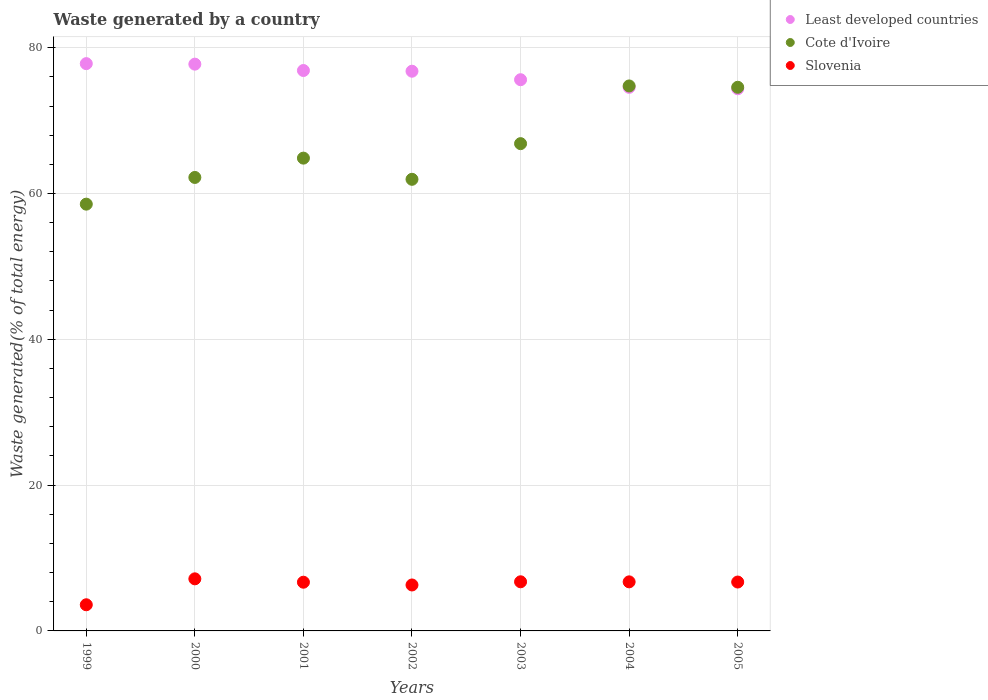How many different coloured dotlines are there?
Offer a terse response. 3. What is the total waste generated in Cote d'Ivoire in 1999?
Keep it short and to the point. 58.54. Across all years, what is the maximum total waste generated in Cote d'Ivoire?
Offer a terse response. 74.76. Across all years, what is the minimum total waste generated in Slovenia?
Provide a short and direct response. 3.59. In which year was the total waste generated in Slovenia minimum?
Your response must be concise. 1999. What is the total total waste generated in Slovenia in the graph?
Ensure brevity in your answer.  43.89. What is the difference between the total waste generated in Least developed countries in 2002 and that in 2004?
Give a very brief answer. 2.21. What is the difference between the total waste generated in Slovenia in 2000 and the total waste generated in Least developed countries in 2005?
Offer a terse response. -67.23. What is the average total waste generated in Cote d'Ivoire per year?
Make the answer very short. 66.25. In the year 2001, what is the difference between the total waste generated in Cote d'Ivoire and total waste generated in Slovenia?
Your response must be concise. 58.17. What is the ratio of the total waste generated in Slovenia in 2001 to that in 2002?
Your response must be concise. 1.06. What is the difference between the highest and the second highest total waste generated in Least developed countries?
Offer a terse response. 0.07. What is the difference between the highest and the lowest total waste generated in Slovenia?
Give a very brief answer. 3.56. Is the total waste generated in Least developed countries strictly greater than the total waste generated in Slovenia over the years?
Provide a short and direct response. Yes. How many years are there in the graph?
Your answer should be very brief. 7. What is the difference between two consecutive major ticks on the Y-axis?
Provide a succinct answer. 20. Are the values on the major ticks of Y-axis written in scientific E-notation?
Ensure brevity in your answer.  No. How many legend labels are there?
Ensure brevity in your answer.  3. What is the title of the graph?
Keep it short and to the point. Waste generated by a country. Does "Sierra Leone" appear as one of the legend labels in the graph?
Your answer should be very brief. No. What is the label or title of the X-axis?
Offer a terse response. Years. What is the label or title of the Y-axis?
Offer a very short reply. Waste generated(% of total energy). What is the Waste generated(% of total energy) in Least developed countries in 1999?
Offer a very short reply. 77.82. What is the Waste generated(% of total energy) in Cote d'Ivoire in 1999?
Provide a succinct answer. 58.54. What is the Waste generated(% of total energy) of Slovenia in 1999?
Ensure brevity in your answer.  3.59. What is the Waste generated(% of total energy) in Least developed countries in 2000?
Give a very brief answer. 77.75. What is the Waste generated(% of total energy) of Cote d'Ivoire in 2000?
Your response must be concise. 62.2. What is the Waste generated(% of total energy) in Slovenia in 2000?
Make the answer very short. 7.14. What is the Waste generated(% of total energy) of Least developed countries in 2001?
Your answer should be compact. 76.87. What is the Waste generated(% of total energy) in Cote d'Ivoire in 2001?
Your answer should be very brief. 64.85. What is the Waste generated(% of total energy) in Slovenia in 2001?
Offer a terse response. 6.68. What is the Waste generated(% of total energy) in Least developed countries in 2002?
Give a very brief answer. 76.78. What is the Waste generated(% of total energy) in Cote d'Ivoire in 2002?
Offer a very short reply. 61.95. What is the Waste generated(% of total energy) in Slovenia in 2002?
Make the answer very short. 6.3. What is the Waste generated(% of total energy) of Least developed countries in 2003?
Provide a succinct answer. 75.61. What is the Waste generated(% of total energy) of Cote d'Ivoire in 2003?
Give a very brief answer. 66.84. What is the Waste generated(% of total energy) of Slovenia in 2003?
Your answer should be compact. 6.74. What is the Waste generated(% of total energy) of Least developed countries in 2004?
Give a very brief answer. 74.56. What is the Waste generated(% of total energy) of Cote d'Ivoire in 2004?
Keep it short and to the point. 74.76. What is the Waste generated(% of total energy) in Slovenia in 2004?
Give a very brief answer. 6.73. What is the Waste generated(% of total energy) in Least developed countries in 2005?
Provide a short and direct response. 74.37. What is the Waste generated(% of total energy) in Cote d'Ivoire in 2005?
Your answer should be very brief. 74.57. What is the Waste generated(% of total energy) of Slovenia in 2005?
Offer a terse response. 6.71. Across all years, what is the maximum Waste generated(% of total energy) in Least developed countries?
Your answer should be compact. 77.82. Across all years, what is the maximum Waste generated(% of total energy) of Cote d'Ivoire?
Ensure brevity in your answer.  74.76. Across all years, what is the maximum Waste generated(% of total energy) in Slovenia?
Ensure brevity in your answer.  7.14. Across all years, what is the minimum Waste generated(% of total energy) of Least developed countries?
Offer a very short reply. 74.37. Across all years, what is the minimum Waste generated(% of total energy) of Cote d'Ivoire?
Offer a terse response. 58.54. Across all years, what is the minimum Waste generated(% of total energy) of Slovenia?
Your response must be concise. 3.59. What is the total Waste generated(% of total energy) in Least developed countries in the graph?
Make the answer very short. 533.76. What is the total Waste generated(% of total energy) in Cote d'Ivoire in the graph?
Make the answer very short. 463.72. What is the total Waste generated(% of total energy) in Slovenia in the graph?
Keep it short and to the point. 43.89. What is the difference between the Waste generated(% of total energy) in Least developed countries in 1999 and that in 2000?
Ensure brevity in your answer.  0.07. What is the difference between the Waste generated(% of total energy) in Cote d'Ivoire in 1999 and that in 2000?
Make the answer very short. -3.66. What is the difference between the Waste generated(% of total energy) in Slovenia in 1999 and that in 2000?
Keep it short and to the point. -3.56. What is the difference between the Waste generated(% of total energy) of Least developed countries in 1999 and that in 2001?
Ensure brevity in your answer.  0.94. What is the difference between the Waste generated(% of total energy) in Cote d'Ivoire in 1999 and that in 2001?
Give a very brief answer. -6.31. What is the difference between the Waste generated(% of total energy) of Slovenia in 1999 and that in 2001?
Ensure brevity in your answer.  -3.09. What is the difference between the Waste generated(% of total energy) of Least developed countries in 1999 and that in 2002?
Offer a terse response. 1.04. What is the difference between the Waste generated(% of total energy) in Cote d'Ivoire in 1999 and that in 2002?
Give a very brief answer. -3.41. What is the difference between the Waste generated(% of total energy) of Slovenia in 1999 and that in 2002?
Ensure brevity in your answer.  -2.72. What is the difference between the Waste generated(% of total energy) of Least developed countries in 1999 and that in 2003?
Provide a short and direct response. 2.21. What is the difference between the Waste generated(% of total energy) of Cote d'Ivoire in 1999 and that in 2003?
Ensure brevity in your answer.  -8.3. What is the difference between the Waste generated(% of total energy) of Slovenia in 1999 and that in 2003?
Your response must be concise. -3.15. What is the difference between the Waste generated(% of total energy) in Least developed countries in 1999 and that in 2004?
Your answer should be compact. 3.25. What is the difference between the Waste generated(% of total energy) in Cote d'Ivoire in 1999 and that in 2004?
Your answer should be very brief. -16.21. What is the difference between the Waste generated(% of total energy) in Slovenia in 1999 and that in 2004?
Give a very brief answer. -3.14. What is the difference between the Waste generated(% of total energy) in Least developed countries in 1999 and that in 2005?
Offer a very short reply. 3.45. What is the difference between the Waste generated(% of total energy) in Cote d'Ivoire in 1999 and that in 2005?
Your answer should be very brief. -16.03. What is the difference between the Waste generated(% of total energy) in Slovenia in 1999 and that in 2005?
Make the answer very short. -3.12. What is the difference between the Waste generated(% of total energy) in Least developed countries in 2000 and that in 2001?
Provide a succinct answer. 0.87. What is the difference between the Waste generated(% of total energy) in Cote d'Ivoire in 2000 and that in 2001?
Offer a terse response. -2.65. What is the difference between the Waste generated(% of total energy) of Slovenia in 2000 and that in 2001?
Your answer should be compact. 0.46. What is the difference between the Waste generated(% of total energy) in Least developed countries in 2000 and that in 2002?
Your response must be concise. 0.97. What is the difference between the Waste generated(% of total energy) of Cote d'Ivoire in 2000 and that in 2002?
Your answer should be very brief. 0.25. What is the difference between the Waste generated(% of total energy) in Slovenia in 2000 and that in 2002?
Offer a very short reply. 0.84. What is the difference between the Waste generated(% of total energy) of Least developed countries in 2000 and that in 2003?
Your response must be concise. 2.13. What is the difference between the Waste generated(% of total energy) in Cote d'Ivoire in 2000 and that in 2003?
Your response must be concise. -4.64. What is the difference between the Waste generated(% of total energy) of Slovenia in 2000 and that in 2003?
Ensure brevity in your answer.  0.41. What is the difference between the Waste generated(% of total energy) in Least developed countries in 2000 and that in 2004?
Keep it short and to the point. 3.18. What is the difference between the Waste generated(% of total energy) in Cote d'Ivoire in 2000 and that in 2004?
Ensure brevity in your answer.  -12.55. What is the difference between the Waste generated(% of total energy) of Slovenia in 2000 and that in 2004?
Keep it short and to the point. 0.41. What is the difference between the Waste generated(% of total energy) of Least developed countries in 2000 and that in 2005?
Ensure brevity in your answer.  3.37. What is the difference between the Waste generated(% of total energy) of Cote d'Ivoire in 2000 and that in 2005?
Ensure brevity in your answer.  -12.37. What is the difference between the Waste generated(% of total energy) in Slovenia in 2000 and that in 2005?
Offer a terse response. 0.44. What is the difference between the Waste generated(% of total energy) of Least developed countries in 2001 and that in 2002?
Provide a succinct answer. 0.1. What is the difference between the Waste generated(% of total energy) of Cote d'Ivoire in 2001 and that in 2002?
Offer a terse response. 2.9. What is the difference between the Waste generated(% of total energy) in Slovenia in 2001 and that in 2002?
Your answer should be compact. 0.38. What is the difference between the Waste generated(% of total energy) in Least developed countries in 2001 and that in 2003?
Your answer should be compact. 1.26. What is the difference between the Waste generated(% of total energy) of Cote d'Ivoire in 2001 and that in 2003?
Make the answer very short. -1.99. What is the difference between the Waste generated(% of total energy) in Slovenia in 2001 and that in 2003?
Provide a short and direct response. -0.06. What is the difference between the Waste generated(% of total energy) of Least developed countries in 2001 and that in 2004?
Offer a very short reply. 2.31. What is the difference between the Waste generated(% of total energy) in Cote d'Ivoire in 2001 and that in 2004?
Make the answer very short. -9.9. What is the difference between the Waste generated(% of total energy) of Slovenia in 2001 and that in 2004?
Provide a succinct answer. -0.05. What is the difference between the Waste generated(% of total energy) of Least developed countries in 2001 and that in 2005?
Your answer should be compact. 2.5. What is the difference between the Waste generated(% of total energy) in Cote d'Ivoire in 2001 and that in 2005?
Keep it short and to the point. -9.72. What is the difference between the Waste generated(% of total energy) in Slovenia in 2001 and that in 2005?
Offer a very short reply. -0.02. What is the difference between the Waste generated(% of total energy) in Least developed countries in 2002 and that in 2003?
Your response must be concise. 1.17. What is the difference between the Waste generated(% of total energy) of Cote d'Ivoire in 2002 and that in 2003?
Provide a succinct answer. -4.89. What is the difference between the Waste generated(% of total energy) of Slovenia in 2002 and that in 2003?
Offer a terse response. -0.44. What is the difference between the Waste generated(% of total energy) in Least developed countries in 2002 and that in 2004?
Your answer should be compact. 2.21. What is the difference between the Waste generated(% of total energy) in Cote d'Ivoire in 2002 and that in 2004?
Make the answer very short. -12.81. What is the difference between the Waste generated(% of total energy) in Slovenia in 2002 and that in 2004?
Offer a very short reply. -0.43. What is the difference between the Waste generated(% of total energy) in Least developed countries in 2002 and that in 2005?
Your answer should be compact. 2.41. What is the difference between the Waste generated(% of total energy) of Cote d'Ivoire in 2002 and that in 2005?
Keep it short and to the point. -12.62. What is the difference between the Waste generated(% of total energy) of Slovenia in 2002 and that in 2005?
Provide a succinct answer. -0.4. What is the difference between the Waste generated(% of total energy) of Least developed countries in 2003 and that in 2004?
Your response must be concise. 1.05. What is the difference between the Waste generated(% of total energy) of Cote d'Ivoire in 2003 and that in 2004?
Offer a very short reply. -7.92. What is the difference between the Waste generated(% of total energy) in Slovenia in 2003 and that in 2004?
Provide a succinct answer. 0.01. What is the difference between the Waste generated(% of total energy) in Least developed countries in 2003 and that in 2005?
Provide a succinct answer. 1.24. What is the difference between the Waste generated(% of total energy) of Cote d'Ivoire in 2003 and that in 2005?
Keep it short and to the point. -7.73. What is the difference between the Waste generated(% of total energy) of Slovenia in 2003 and that in 2005?
Keep it short and to the point. 0.03. What is the difference between the Waste generated(% of total energy) of Least developed countries in 2004 and that in 2005?
Provide a succinct answer. 0.19. What is the difference between the Waste generated(% of total energy) in Cote d'Ivoire in 2004 and that in 2005?
Provide a succinct answer. 0.18. What is the difference between the Waste generated(% of total energy) of Slovenia in 2004 and that in 2005?
Offer a very short reply. 0.02. What is the difference between the Waste generated(% of total energy) of Least developed countries in 1999 and the Waste generated(% of total energy) of Cote d'Ivoire in 2000?
Offer a terse response. 15.61. What is the difference between the Waste generated(% of total energy) in Least developed countries in 1999 and the Waste generated(% of total energy) in Slovenia in 2000?
Make the answer very short. 70.67. What is the difference between the Waste generated(% of total energy) in Cote d'Ivoire in 1999 and the Waste generated(% of total energy) in Slovenia in 2000?
Make the answer very short. 51.4. What is the difference between the Waste generated(% of total energy) in Least developed countries in 1999 and the Waste generated(% of total energy) in Cote d'Ivoire in 2001?
Give a very brief answer. 12.96. What is the difference between the Waste generated(% of total energy) of Least developed countries in 1999 and the Waste generated(% of total energy) of Slovenia in 2001?
Keep it short and to the point. 71.13. What is the difference between the Waste generated(% of total energy) of Cote d'Ivoire in 1999 and the Waste generated(% of total energy) of Slovenia in 2001?
Provide a short and direct response. 51.86. What is the difference between the Waste generated(% of total energy) of Least developed countries in 1999 and the Waste generated(% of total energy) of Cote d'Ivoire in 2002?
Your response must be concise. 15.87. What is the difference between the Waste generated(% of total energy) of Least developed countries in 1999 and the Waste generated(% of total energy) of Slovenia in 2002?
Ensure brevity in your answer.  71.51. What is the difference between the Waste generated(% of total energy) in Cote d'Ivoire in 1999 and the Waste generated(% of total energy) in Slovenia in 2002?
Your response must be concise. 52.24. What is the difference between the Waste generated(% of total energy) in Least developed countries in 1999 and the Waste generated(% of total energy) in Cote d'Ivoire in 2003?
Your response must be concise. 10.98. What is the difference between the Waste generated(% of total energy) in Least developed countries in 1999 and the Waste generated(% of total energy) in Slovenia in 2003?
Keep it short and to the point. 71.08. What is the difference between the Waste generated(% of total energy) in Cote d'Ivoire in 1999 and the Waste generated(% of total energy) in Slovenia in 2003?
Provide a short and direct response. 51.8. What is the difference between the Waste generated(% of total energy) of Least developed countries in 1999 and the Waste generated(% of total energy) of Cote d'Ivoire in 2004?
Keep it short and to the point. 3.06. What is the difference between the Waste generated(% of total energy) of Least developed countries in 1999 and the Waste generated(% of total energy) of Slovenia in 2004?
Make the answer very short. 71.09. What is the difference between the Waste generated(% of total energy) of Cote d'Ivoire in 1999 and the Waste generated(% of total energy) of Slovenia in 2004?
Keep it short and to the point. 51.81. What is the difference between the Waste generated(% of total energy) in Least developed countries in 1999 and the Waste generated(% of total energy) in Cote d'Ivoire in 2005?
Your answer should be very brief. 3.24. What is the difference between the Waste generated(% of total energy) of Least developed countries in 1999 and the Waste generated(% of total energy) of Slovenia in 2005?
Offer a very short reply. 71.11. What is the difference between the Waste generated(% of total energy) of Cote d'Ivoire in 1999 and the Waste generated(% of total energy) of Slovenia in 2005?
Offer a very short reply. 51.84. What is the difference between the Waste generated(% of total energy) of Least developed countries in 2000 and the Waste generated(% of total energy) of Cote d'Ivoire in 2001?
Your response must be concise. 12.89. What is the difference between the Waste generated(% of total energy) in Least developed countries in 2000 and the Waste generated(% of total energy) in Slovenia in 2001?
Offer a very short reply. 71.06. What is the difference between the Waste generated(% of total energy) of Cote d'Ivoire in 2000 and the Waste generated(% of total energy) of Slovenia in 2001?
Provide a succinct answer. 55.52. What is the difference between the Waste generated(% of total energy) of Least developed countries in 2000 and the Waste generated(% of total energy) of Cote d'Ivoire in 2002?
Your response must be concise. 15.8. What is the difference between the Waste generated(% of total energy) of Least developed countries in 2000 and the Waste generated(% of total energy) of Slovenia in 2002?
Ensure brevity in your answer.  71.44. What is the difference between the Waste generated(% of total energy) of Cote d'Ivoire in 2000 and the Waste generated(% of total energy) of Slovenia in 2002?
Make the answer very short. 55.9. What is the difference between the Waste generated(% of total energy) in Least developed countries in 2000 and the Waste generated(% of total energy) in Cote d'Ivoire in 2003?
Make the answer very short. 10.9. What is the difference between the Waste generated(% of total energy) in Least developed countries in 2000 and the Waste generated(% of total energy) in Slovenia in 2003?
Your answer should be compact. 71.01. What is the difference between the Waste generated(% of total energy) in Cote d'Ivoire in 2000 and the Waste generated(% of total energy) in Slovenia in 2003?
Offer a terse response. 55.46. What is the difference between the Waste generated(% of total energy) of Least developed countries in 2000 and the Waste generated(% of total energy) of Cote d'Ivoire in 2004?
Offer a very short reply. 2.99. What is the difference between the Waste generated(% of total energy) of Least developed countries in 2000 and the Waste generated(% of total energy) of Slovenia in 2004?
Your answer should be compact. 71.01. What is the difference between the Waste generated(% of total energy) of Cote d'Ivoire in 2000 and the Waste generated(% of total energy) of Slovenia in 2004?
Provide a succinct answer. 55.47. What is the difference between the Waste generated(% of total energy) in Least developed countries in 2000 and the Waste generated(% of total energy) in Cote d'Ivoire in 2005?
Your answer should be compact. 3.17. What is the difference between the Waste generated(% of total energy) of Least developed countries in 2000 and the Waste generated(% of total energy) of Slovenia in 2005?
Keep it short and to the point. 71.04. What is the difference between the Waste generated(% of total energy) in Cote d'Ivoire in 2000 and the Waste generated(% of total energy) in Slovenia in 2005?
Your answer should be very brief. 55.5. What is the difference between the Waste generated(% of total energy) in Least developed countries in 2001 and the Waste generated(% of total energy) in Cote d'Ivoire in 2002?
Keep it short and to the point. 14.92. What is the difference between the Waste generated(% of total energy) of Least developed countries in 2001 and the Waste generated(% of total energy) of Slovenia in 2002?
Your answer should be compact. 70.57. What is the difference between the Waste generated(% of total energy) in Cote d'Ivoire in 2001 and the Waste generated(% of total energy) in Slovenia in 2002?
Offer a very short reply. 58.55. What is the difference between the Waste generated(% of total energy) in Least developed countries in 2001 and the Waste generated(% of total energy) in Cote d'Ivoire in 2003?
Make the answer very short. 10.03. What is the difference between the Waste generated(% of total energy) in Least developed countries in 2001 and the Waste generated(% of total energy) in Slovenia in 2003?
Offer a very short reply. 70.13. What is the difference between the Waste generated(% of total energy) of Cote d'Ivoire in 2001 and the Waste generated(% of total energy) of Slovenia in 2003?
Provide a short and direct response. 58.11. What is the difference between the Waste generated(% of total energy) in Least developed countries in 2001 and the Waste generated(% of total energy) in Cote d'Ivoire in 2004?
Provide a short and direct response. 2.12. What is the difference between the Waste generated(% of total energy) of Least developed countries in 2001 and the Waste generated(% of total energy) of Slovenia in 2004?
Keep it short and to the point. 70.14. What is the difference between the Waste generated(% of total energy) in Cote d'Ivoire in 2001 and the Waste generated(% of total energy) in Slovenia in 2004?
Ensure brevity in your answer.  58.12. What is the difference between the Waste generated(% of total energy) of Least developed countries in 2001 and the Waste generated(% of total energy) of Cote d'Ivoire in 2005?
Provide a short and direct response. 2.3. What is the difference between the Waste generated(% of total energy) in Least developed countries in 2001 and the Waste generated(% of total energy) in Slovenia in 2005?
Give a very brief answer. 70.17. What is the difference between the Waste generated(% of total energy) of Cote d'Ivoire in 2001 and the Waste generated(% of total energy) of Slovenia in 2005?
Your answer should be very brief. 58.15. What is the difference between the Waste generated(% of total energy) of Least developed countries in 2002 and the Waste generated(% of total energy) of Cote d'Ivoire in 2003?
Give a very brief answer. 9.94. What is the difference between the Waste generated(% of total energy) in Least developed countries in 2002 and the Waste generated(% of total energy) in Slovenia in 2003?
Offer a terse response. 70.04. What is the difference between the Waste generated(% of total energy) in Cote d'Ivoire in 2002 and the Waste generated(% of total energy) in Slovenia in 2003?
Keep it short and to the point. 55.21. What is the difference between the Waste generated(% of total energy) of Least developed countries in 2002 and the Waste generated(% of total energy) of Cote d'Ivoire in 2004?
Make the answer very short. 2.02. What is the difference between the Waste generated(% of total energy) in Least developed countries in 2002 and the Waste generated(% of total energy) in Slovenia in 2004?
Your response must be concise. 70.05. What is the difference between the Waste generated(% of total energy) in Cote d'Ivoire in 2002 and the Waste generated(% of total energy) in Slovenia in 2004?
Provide a succinct answer. 55.22. What is the difference between the Waste generated(% of total energy) of Least developed countries in 2002 and the Waste generated(% of total energy) of Cote d'Ivoire in 2005?
Make the answer very short. 2.2. What is the difference between the Waste generated(% of total energy) in Least developed countries in 2002 and the Waste generated(% of total energy) in Slovenia in 2005?
Provide a short and direct response. 70.07. What is the difference between the Waste generated(% of total energy) in Cote d'Ivoire in 2002 and the Waste generated(% of total energy) in Slovenia in 2005?
Offer a very short reply. 55.24. What is the difference between the Waste generated(% of total energy) of Least developed countries in 2003 and the Waste generated(% of total energy) of Cote d'Ivoire in 2004?
Make the answer very short. 0.85. What is the difference between the Waste generated(% of total energy) of Least developed countries in 2003 and the Waste generated(% of total energy) of Slovenia in 2004?
Give a very brief answer. 68.88. What is the difference between the Waste generated(% of total energy) in Cote d'Ivoire in 2003 and the Waste generated(% of total energy) in Slovenia in 2004?
Make the answer very short. 60.11. What is the difference between the Waste generated(% of total energy) of Least developed countries in 2003 and the Waste generated(% of total energy) of Cote d'Ivoire in 2005?
Provide a short and direct response. 1.04. What is the difference between the Waste generated(% of total energy) in Least developed countries in 2003 and the Waste generated(% of total energy) in Slovenia in 2005?
Ensure brevity in your answer.  68.9. What is the difference between the Waste generated(% of total energy) of Cote d'Ivoire in 2003 and the Waste generated(% of total energy) of Slovenia in 2005?
Offer a very short reply. 60.13. What is the difference between the Waste generated(% of total energy) of Least developed countries in 2004 and the Waste generated(% of total energy) of Cote d'Ivoire in 2005?
Give a very brief answer. -0.01. What is the difference between the Waste generated(% of total energy) of Least developed countries in 2004 and the Waste generated(% of total energy) of Slovenia in 2005?
Offer a terse response. 67.86. What is the difference between the Waste generated(% of total energy) of Cote d'Ivoire in 2004 and the Waste generated(% of total energy) of Slovenia in 2005?
Make the answer very short. 68.05. What is the average Waste generated(% of total energy) of Least developed countries per year?
Provide a short and direct response. 76.25. What is the average Waste generated(% of total energy) in Cote d'Ivoire per year?
Your answer should be compact. 66.25. What is the average Waste generated(% of total energy) in Slovenia per year?
Ensure brevity in your answer.  6.27. In the year 1999, what is the difference between the Waste generated(% of total energy) in Least developed countries and Waste generated(% of total energy) in Cote d'Ivoire?
Keep it short and to the point. 19.27. In the year 1999, what is the difference between the Waste generated(% of total energy) of Least developed countries and Waste generated(% of total energy) of Slovenia?
Your answer should be very brief. 74.23. In the year 1999, what is the difference between the Waste generated(% of total energy) in Cote d'Ivoire and Waste generated(% of total energy) in Slovenia?
Provide a short and direct response. 54.95. In the year 2000, what is the difference between the Waste generated(% of total energy) of Least developed countries and Waste generated(% of total energy) of Cote d'Ivoire?
Keep it short and to the point. 15.54. In the year 2000, what is the difference between the Waste generated(% of total energy) of Least developed countries and Waste generated(% of total energy) of Slovenia?
Offer a very short reply. 70.6. In the year 2000, what is the difference between the Waste generated(% of total energy) in Cote d'Ivoire and Waste generated(% of total energy) in Slovenia?
Offer a terse response. 55.06. In the year 2001, what is the difference between the Waste generated(% of total energy) of Least developed countries and Waste generated(% of total energy) of Cote d'Ivoire?
Your answer should be very brief. 12.02. In the year 2001, what is the difference between the Waste generated(% of total energy) of Least developed countries and Waste generated(% of total energy) of Slovenia?
Keep it short and to the point. 70.19. In the year 2001, what is the difference between the Waste generated(% of total energy) of Cote d'Ivoire and Waste generated(% of total energy) of Slovenia?
Offer a very short reply. 58.17. In the year 2002, what is the difference between the Waste generated(% of total energy) in Least developed countries and Waste generated(% of total energy) in Cote d'Ivoire?
Ensure brevity in your answer.  14.83. In the year 2002, what is the difference between the Waste generated(% of total energy) of Least developed countries and Waste generated(% of total energy) of Slovenia?
Keep it short and to the point. 70.47. In the year 2002, what is the difference between the Waste generated(% of total energy) of Cote d'Ivoire and Waste generated(% of total energy) of Slovenia?
Your response must be concise. 55.65. In the year 2003, what is the difference between the Waste generated(% of total energy) in Least developed countries and Waste generated(% of total energy) in Cote d'Ivoire?
Give a very brief answer. 8.77. In the year 2003, what is the difference between the Waste generated(% of total energy) of Least developed countries and Waste generated(% of total energy) of Slovenia?
Offer a terse response. 68.87. In the year 2003, what is the difference between the Waste generated(% of total energy) in Cote d'Ivoire and Waste generated(% of total energy) in Slovenia?
Provide a succinct answer. 60.1. In the year 2004, what is the difference between the Waste generated(% of total energy) in Least developed countries and Waste generated(% of total energy) in Cote d'Ivoire?
Your answer should be compact. -0.19. In the year 2004, what is the difference between the Waste generated(% of total energy) in Least developed countries and Waste generated(% of total energy) in Slovenia?
Offer a terse response. 67.83. In the year 2004, what is the difference between the Waste generated(% of total energy) in Cote d'Ivoire and Waste generated(% of total energy) in Slovenia?
Offer a terse response. 68.03. In the year 2005, what is the difference between the Waste generated(% of total energy) in Least developed countries and Waste generated(% of total energy) in Cote d'Ivoire?
Provide a succinct answer. -0.2. In the year 2005, what is the difference between the Waste generated(% of total energy) of Least developed countries and Waste generated(% of total energy) of Slovenia?
Your answer should be very brief. 67.66. In the year 2005, what is the difference between the Waste generated(% of total energy) of Cote d'Ivoire and Waste generated(% of total energy) of Slovenia?
Provide a short and direct response. 67.87. What is the ratio of the Waste generated(% of total energy) of Least developed countries in 1999 to that in 2000?
Your answer should be compact. 1. What is the ratio of the Waste generated(% of total energy) in Cote d'Ivoire in 1999 to that in 2000?
Provide a short and direct response. 0.94. What is the ratio of the Waste generated(% of total energy) of Slovenia in 1999 to that in 2000?
Offer a terse response. 0.5. What is the ratio of the Waste generated(% of total energy) of Least developed countries in 1999 to that in 2001?
Give a very brief answer. 1.01. What is the ratio of the Waste generated(% of total energy) of Cote d'Ivoire in 1999 to that in 2001?
Offer a very short reply. 0.9. What is the ratio of the Waste generated(% of total energy) of Slovenia in 1999 to that in 2001?
Offer a very short reply. 0.54. What is the ratio of the Waste generated(% of total energy) of Least developed countries in 1999 to that in 2002?
Provide a succinct answer. 1.01. What is the ratio of the Waste generated(% of total energy) of Cote d'Ivoire in 1999 to that in 2002?
Offer a very short reply. 0.94. What is the ratio of the Waste generated(% of total energy) of Slovenia in 1999 to that in 2002?
Offer a terse response. 0.57. What is the ratio of the Waste generated(% of total energy) in Least developed countries in 1999 to that in 2003?
Offer a terse response. 1.03. What is the ratio of the Waste generated(% of total energy) of Cote d'Ivoire in 1999 to that in 2003?
Offer a very short reply. 0.88. What is the ratio of the Waste generated(% of total energy) of Slovenia in 1999 to that in 2003?
Ensure brevity in your answer.  0.53. What is the ratio of the Waste generated(% of total energy) in Least developed countries in 1999 to that in 2004?
Give a very brief answer. 1.04. What is the ratio of the Waste generated(% of total energy) of Cote d'Ivoire in 1999 to that in 2004?
Provide a succinct answer. 0.78. What is the ratio of the Waste generated(% of total energy) of Slovenia in 1999 to that in 2004?
Keep it short and to the point. 0.53. What is the ratio of the Waste generated(% of total energy) of Least developed countries in 1999 to that in 2005?
Offer a very short reply. 1.05. What is the ratio of the Waste generated(% of total energy) in Cote d'Ivoire in 1999 to that in 2005?
Your answer should be very brief. 0.79. What is the ratio of the Waste generated(% of total energy) in Slovenia in 1999 to that in 2005?
Provide a short and direct response. 0.54. What is the ratio of the Waste generated(% of total energy) of Least developed countries in 2000 to that in 2001?
Ensure brevity in your answer.  1.01. What is the ratio of the Waste generated(% of total energy) of Cote d'Ivoire in 2000 to that in 2001?
Your response must be concise. 0.96. What is the ratio of the Waste generated(% of total energy) of Slovenia in 2000 to that in 2001?
Your response must be concise. 1.07. What is the ratio of the Waste generated(% of total energy) of Least developed countries in 2000 to that in 2002?
Provide a succinct answer. 1.01. What is the ratio of the Waste generated(% of total energy) of Slovenia in 2000 to that in 2002?
Your answer should be very brief. 1.13. What is the ratio of the Waste generated(% of total energy) of Least developed countries in 2000 to that in 2003?
Offer a very short reply. 1.03. What is the ratio of the Waste generated(% of total energy) in Cote d'Ivoire in 2000 to that in 2003?
Give a very brief answer. 0.93. What is the ratio of the Waste generated(% of total energy) in Slovenia in 2000 to that in 2003?
Make the answer very short. 1.06. What is the ratio of the Waste generated(% of total energy) in Least developed countries in 2000 to that in 2004?
Your answer should be compact. 1.04. What is the ratio of the Waste generated(% of total energy) in Cote d'Ivoire in 2000 to that in 2004?
Your answer should be compact. 0.83. What is the ratio of the Waste generated(% of total energy) in Slovenia in 2000 to that in 2004?
Your answer should be compact. 1.06. What is the ratio of the Waste generated(% of total energy) in Least developed countries in 2000 to that in 2005?
Make the answer very short. 1.05. What is the ratio of the Waste generated(% of total energy) in Cote d'Ivoire in 2000 to that in 2005?
Ensure brevity in your answer.  0.83. What is the ratio of the Waste generated(% of total energy) in Slovenia in 2000 to that in 2005?
Ensure brevity in your answer.  1.07. What is the ratio of the Waste generated(% of total energy) in Least developed countries in 2001 to that in 2002?
Offer a very short reply. 1. What is the ratio of the Waste generated(% of total energy) in Cote d'Ivoire in 2001 to that in 2002?
Offer a very short reply. 1.05. What is the ratio of the Waste generated(% of total energy) in Slovenia in 2001 to that in 2002?
Your answer should be very brief. 1.06. What is the ratio of the Waste generated(% of total energy) in Least developed countries in 2001 to that in 2003?
Your answer should be very brief. 1.02. What is the ratio of the Waste generated(% of total energy) of Cote d'Ivoire in 2001 to that in 2003?
Your response must be concise. 0.97. What is the ratio of the Waste generated(% of total energy) in Slovenia in 2001 to that in 2003?
Your answer should be compact. 0.99. What is the ratio of the Waste generated(% of total energy) of Least developed countries in 2001 to that in 2004?
Provide a succinct answer. 1.03. What is the ratio of the Waste generated(% of total energy) in Cote d'Ivoire in 2001 to that in 2004?
Offer a terse response. 0.87. What is the ratio of the Waste generated(% of total energy) in Slovenia in 2001 to that in 2004?
Offer a very short reply. 0.99. What is the ratio of the Waste generated(% of total energy) of Least developed countries in 2001 to that in 2005?
Your answer should be compact. 1.03. What is the ratio of the Waste generated(% of total energy) in Cote d'Ivoire in 2001 to that in 2005?
Make the answer very short. 0.87. What is the ratio of the Waste generated(% of total energy) in Least developed countries in 2002 to that in 2003?
Your answer should be very brief. 1.02. What is the ratio of the Waste generated(% of total energy) of Cote d'Ivoire in 2002 to that in 2003?
Ensure brevity in your answer.  0.93. What is the ratio of the Waste generated(% of total energy) of Slovenia in 2002 to that in 2003?
Keep it short and to the point. 0.94. What is the ratio of the Waste generated(% of total energy) of Least developed countries in 2002 to that in 2004?
Provide a short and direct response. 1.03. What is the ratio of the Waste generated(% of total energy) in Cote d'Ivoire in 2002 to that in 2004?
Provide a short and direct response. 0.83. What is the ratio of the Waste generated(% of total energy) in Slovenia in 2002 to that in 2004?
Give a very brief answer. 0.94. What is the ratio of the Waste generated(% of total energy) in Least developed countries in 2002 to that in 2005?
Ensure brevity in your answer.  1.03. What is the ratio of the Waste generated(% of total energy) in Cote d'Ivoire in 2002 to that in 2005?
Make the answer very short. 0.83. What is the ratio of the Waste generated(% of total energy) in Slovenia in 2002 to that in 2005?
Offer a terse response. 0.94. What is the ratio of the Waste generated(% of total energy) of Least developed countries in 2003 to that in 2004?
Your response must be concise. 1.01. What is the ratio of the Waste generated(% of total energy) of Cote d'Ivoire in 2003 to that in 2004?
Offer a very short reply. 0.89. What is the ratio of the Waste generated(% of total energy) in Least developed countries in 2003 to that in 2005?
Provide a short and direct response. 1.02. What is the ratio of the Waste generated(% of total energy) in Cote d'Ivoire in 2003 to that in 2005?
Offer a terse response. 0.9. What is the ratio of the Waste generated(% of total energy) of Slovenia in 2004 to that in 2005?
Keep it short and to the point. 1. What is the difference between the highest and the second highest Waste generated(% of total energy) in Least developed countries?
Your answer should be very brief. 0.07. What is the difference between the highest and the second highest Waste generated(% of total energy) in Cote d'Ivoire?
Offer a terse response. 0.18. What is the difference between the highest and the second highest Waste generated(% of total energy) of Slovenia?
Give a very brief answer. 0.41. What is the difference between the highest and the lowest Waste generated(% of total energy) of Least developed countries?
Provide a short and direct response. 3.45. What is the difference between the highest and the lowest Waste generated(% of total energy) in Cote d'Ivoire?
Offer a very short reply. 16.21. What is the difference between the highest and the lowest Waste generated(% of total energy) of Slovenia?
Keep it short and to the point. 3.56. 